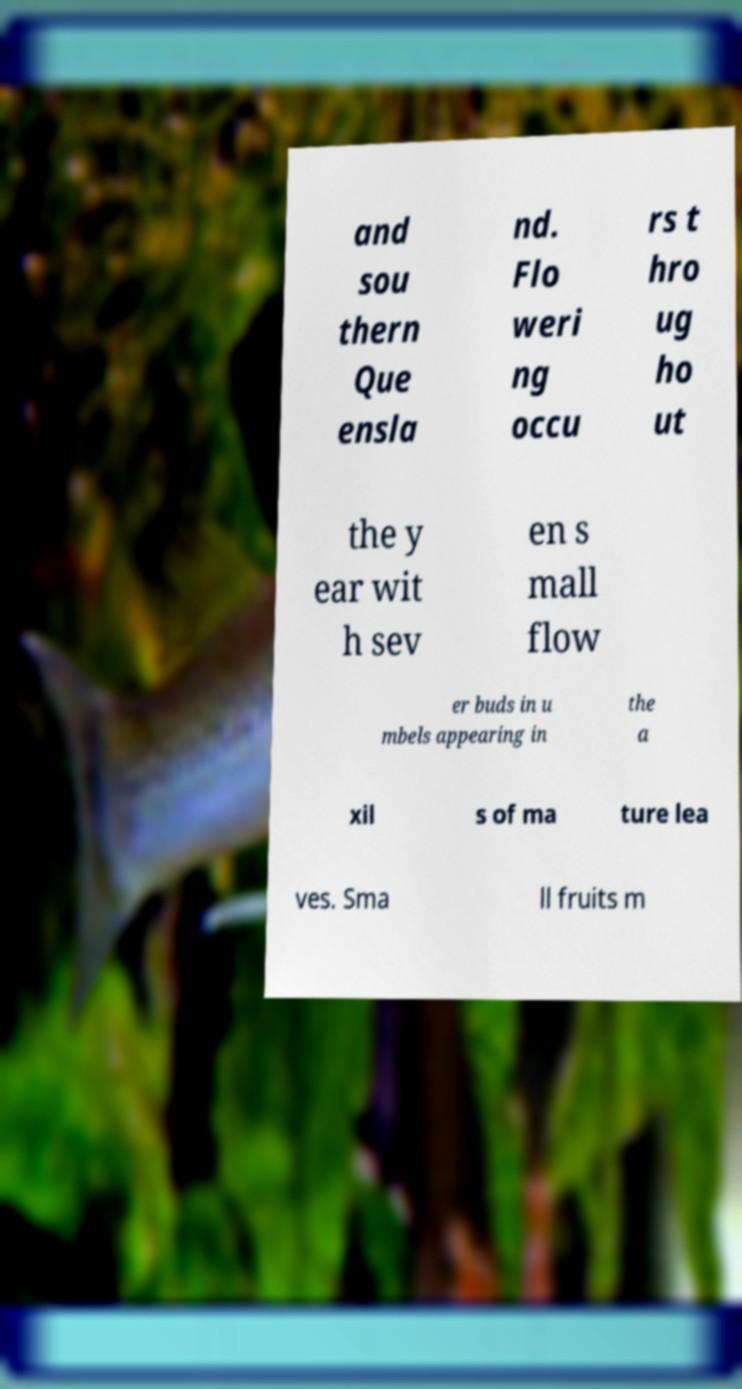I need the written content from this picture converted into text. Can you do that? and sou thern Que ensla nd. Flo weri ng occu rs t hro ug ho ut the y ear wit h sev en s mall flow er buds in u mbels appearing in the a xil s of ma ture lea ves. Sma ll fruits m 